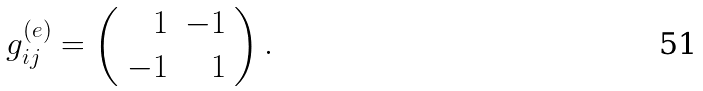Convert formula to latex. <formula><loc_0><loc_0><loc_500><loc_500>g ^ { ( e ) } _ { i j } = \left ( \begin{array} { r r } 1 & - 1 \\ - 1 & 1 \end{array} \right ) .</formula> 